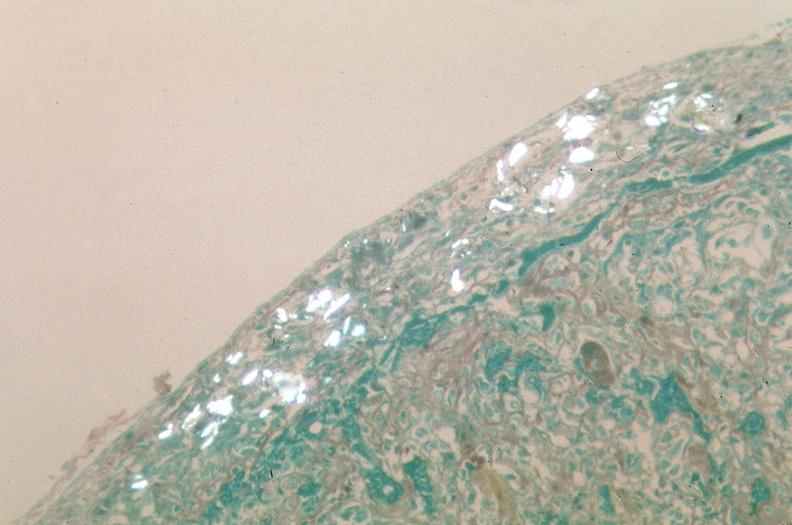how many antitrypsin was talc used to sclerose emphysematous lung, alpha-deficiency?
Answer the question using a single word or phrase. 1 